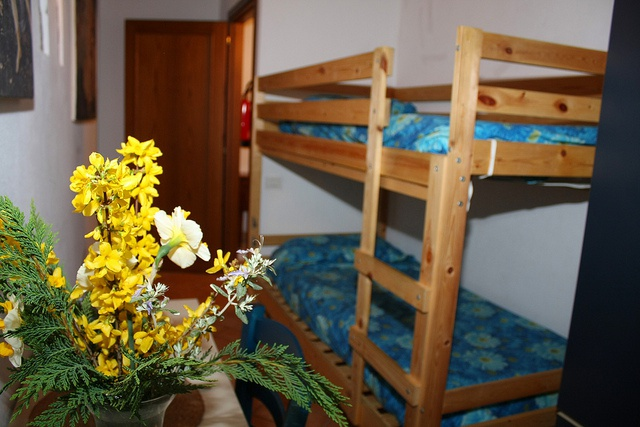Describe the objects in this image and their specific colors. I can see bed in black, brown, darkgray, and maroon tones, potted plant in black, darkgreen, maroon, and gold tones, and vase in black, darkgreen, and gray tones in this image. 